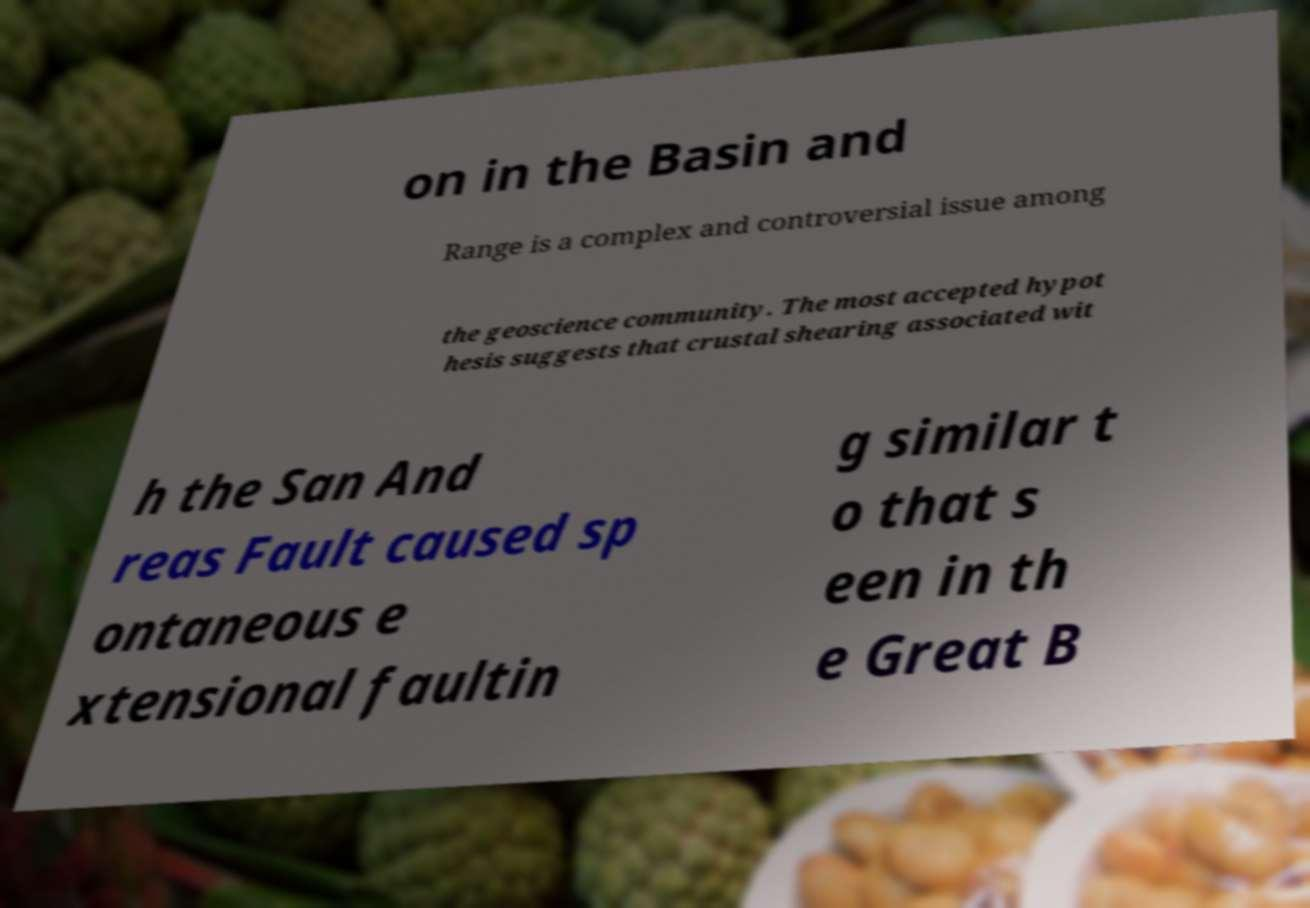Can you read and provide the text displayed in the image?This photo seems to have some interesting text. Can you extract and type it out for me? on in the Basin and Range is a complex and controversial issue among the geoscience community. The most accepted hypot hesis suggests that crustal shearing associated wit h the San And reas Fault caused sp ontaneous e xtensional faultin g similar t o that s een in th e Great B 